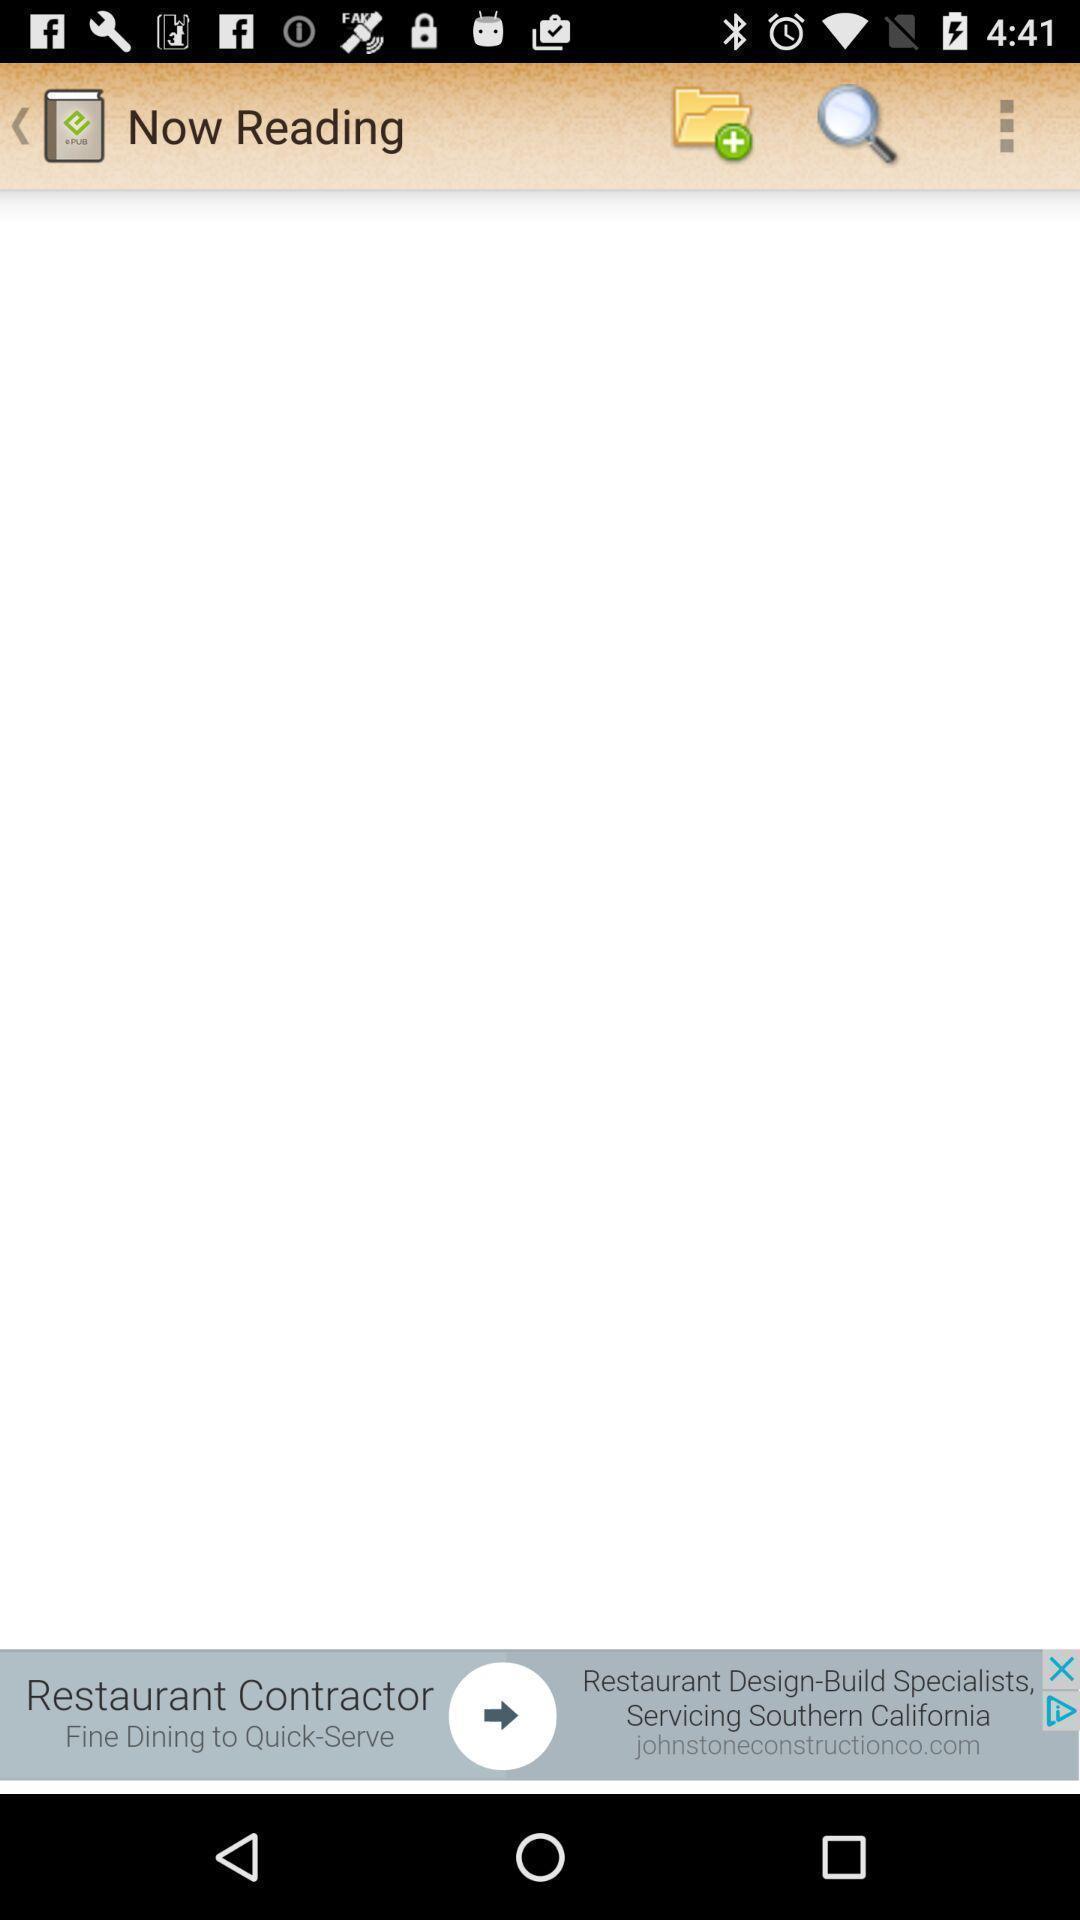Give me a narrative description of this picture. Page showing different option available in app. 